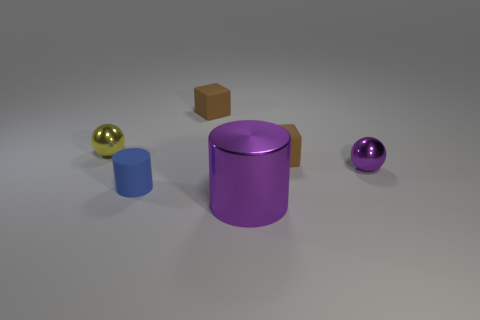What number of small yellow objects are the same material as the small purple sphere?
Ensure brevity in your answer.  1. What is the size of the purple thing that is the same shape as the tiny yellow thing?
Keep it short and to the point. Small. There is a large object; are there any balls on the left side of it?
Your answer should be compact. Yes. What is the tiny yellow thing made of?
Provide a short and direct response. Metal. Do the metal object to the right of the purple metallic cylinder and the large metal thing have the same color?
Your answer should be very brief. Yes. There is a matte object that is the same shape as the large purple metallic object; what is its color?
Your response must be concise. Blue. What is the cylinder that is behind the big purple metallic object made of?
Give a very brief answer. Rubber. The metal cylinder has what color?
Ensure brevity in your answer.  Purple. Does the thing left of the blue rubber thing have the same size as the small matte cylinder?
Your answer should be very brief. Yes. The block behind the brown rubber object in front of the brown rubber thing that is to the left of the big purple object is made of what material?
Your response must be concise. Rubber. 